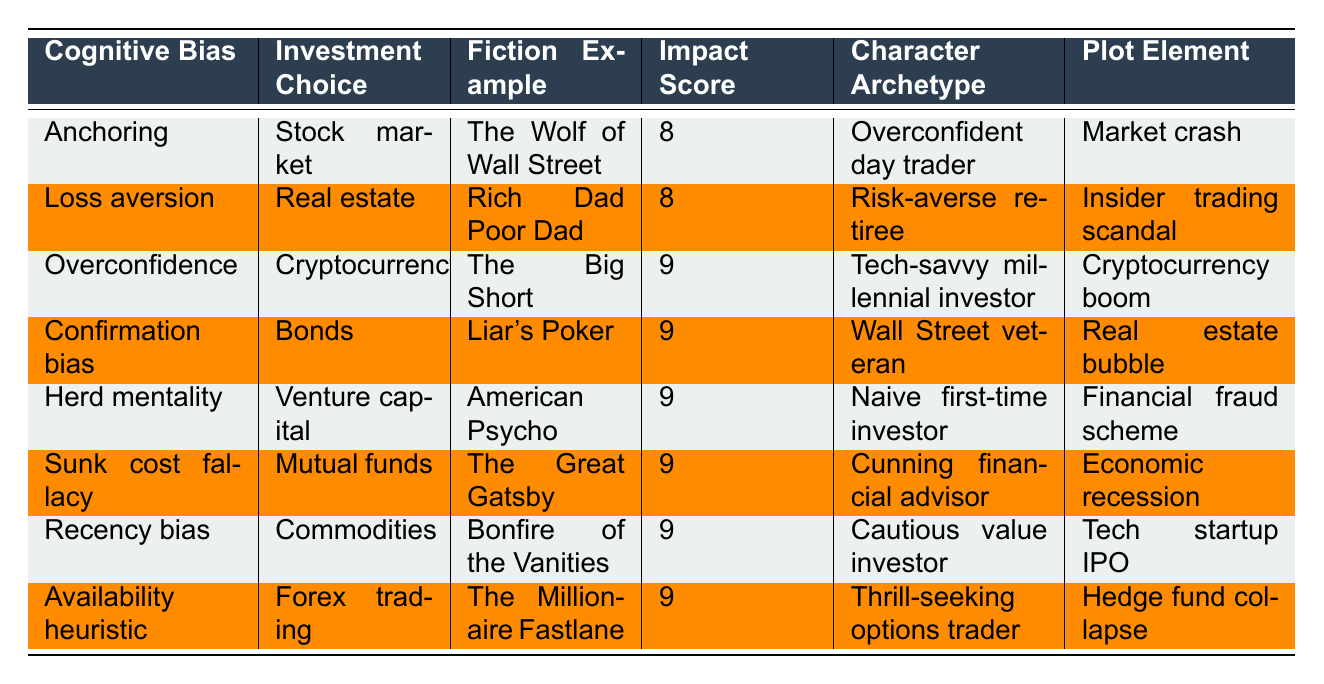What is the cognitive bias most associated with the 'Tech-savvy millennial investor'? Referring to the table, the 'Tech-savvy millennial investor' is associated with the cognitive bias 'Overconfidence' in the context of cryptocurrency, with an impact score of 9.
Answer: Overconfidence Which investment choice has the highest impact score associated with 'Loss aversion'? Looking at the table, 'Loss aversion' is associated with the investment choice 'Real estate,' which has an impact score of 8. This is the highest score among options associated with 'Loss aversion.'
Answer: Real estate Is there a character archetype associated with 'Herd mentality'? The table shows that the character archetype associated with 'Herd mentality' is the 'Naive first-time investor.'
Answer: Yes What is the average impact score for the investment choices listed in the table? To find the average, sum the impact scores of all investment choices: (8 + 8 + 9 + 9 + 9 + 9 + 9 + 9) = 70. There are 8 investment choices, so the average is 70 / 8 = 8.75.
Answer: 8.75 Which cognitive bias is tied to the 'Cunning financial advisor'? The table indicates that the 'Cunning financial advisor' is associated with 'Sunk cost fallacy' in the context of mutual funds, which has an impact score of 9.
Answer: Sunk cost fallacy How does the impact score of 'Herd mentality' compare to 'Anchoring'? The impact score for 'Herd mentality' is 9, while the score for 'Anchoring' is 8. The difference is 9 - 8 = 1, meaning 'Herd mentality' has a higher score.
Answer: 1 What plot element is linked to the 'Wall Street veteran'? According to the table, the 'Wall Street veteran' is linked to the plot element 'Real estate bubble.'
Answer: Real estate bubble What is the character archetype related to the highest impact score among the biases? The highest impact score (9) in the table is associated with multiple character archetypes: 'Tech-savvy millennial investor,' 'Naive first-time investor,' 'Cunning financial advisor,' 'Cautious value investor,' and 'Thrill-seeking options trader.'
Answer: Five character archetypes Which investment choice and cognitive bias combination has the lowest impact score? The table indicates that 'Forex trading' combined with 'Availability heuristic' has the lowest impact score of 9, as it is not lower than any other combinations shown.
Answer: Forex trading and Availability heuristic Is 'The Big Short' associated with a lower or higher impact score than 'Rich Dad Poor Dad'? 'The Big Short' has an impact score of 9, while 'Rich Dad Poor Dad' has a score of 8. Therefore, 'The Big Short' is associated with a higher score than 'Rich Dad Poor Dad.'
Answer: Higher 